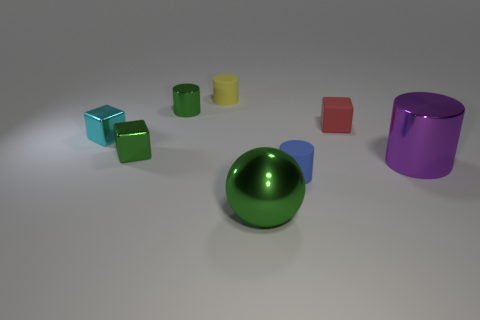Subtract all small metal blocks. How many blocks are left? 1 Subtract all green cylinders. How many cylinders are left? 3 Add 1 big blue rubber balls. How many objects exist? 9 Subtract all spheres. How many objects are left? 7 Subtract all gray cubes. Subtract all cyan cylinders. How many cubes are left? 3 Subtract 0 yellow cubes. How many objects are left? 8 Subtract all tiny red rubber objects. Subtract all blue cylinders. How many objects are left? 6 Add 7 small red rubber cubes. How many small red rubber cubes are left? 8 Add 1 big purple metal cylinders. How many big purple metal cylinders exist? 2 